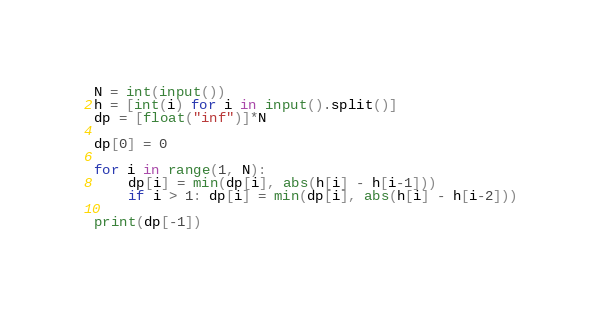<code> <loc_0><loc_0><loc_500><loc_500><_Python_>N = int(input())
h = [int(i) for i in input().split()]
dp = [float("inf")]*N

dp[0] = 0

for i in range(1, N):
    dp[i] = min(dp[i], abs(h[i] - h[i-1]))
    if i > 1: dp[i] = min(dp[i], abs(h[i] - h[i-2]))

print(dp[-1])</code> 